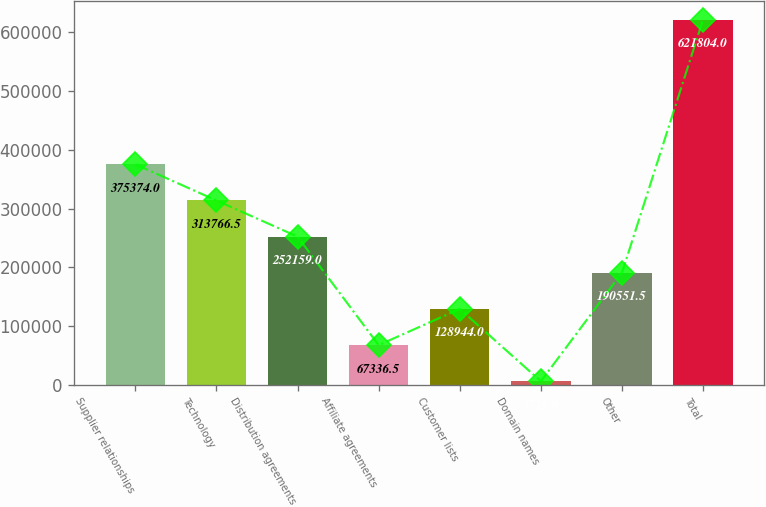Convert chart to OTSL. <chart><loc_0><loc_0><loc_500><loc_500><bar_chart><fcel>Supplier relationships<fcel>Technology<fcel>Distribution agreements<fcel>Affiliate agreements<fcel>Customer lists<fcel>Domain names<fcel>Other<fcel>Total<nl><fcel>375374<fcel>313766<fcel>252159<fcel>67336.5<fcel>128944<fcel>5729<fcel>190552<fcel>621804<nl></chart> 